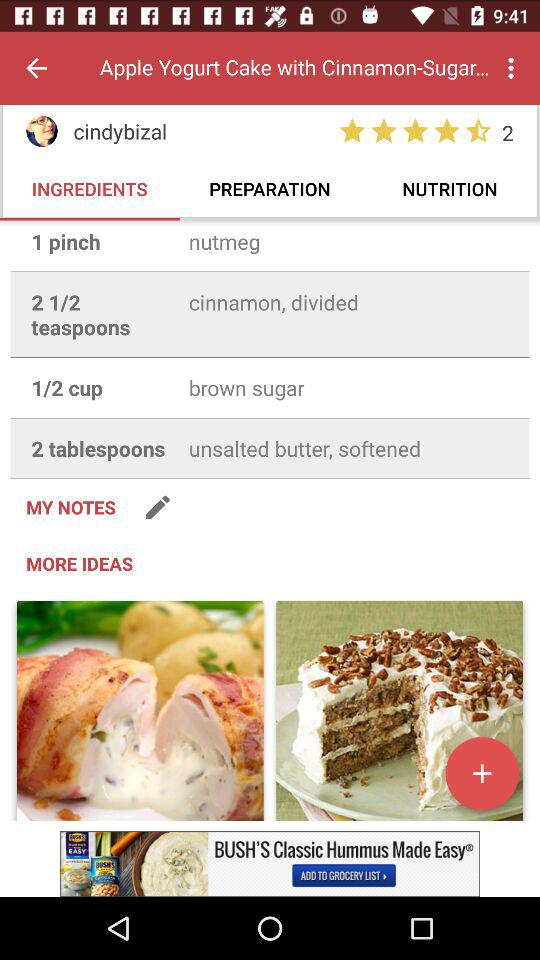How many ingredients are there in this recipe?
Answer the question using a single word or phrase. 6 